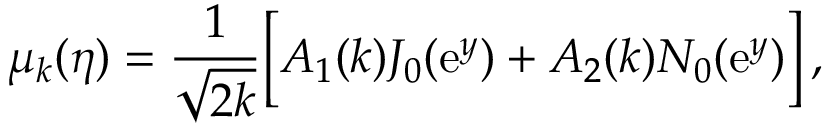Convert formula to latex. <formula><loc_0><loc_0><loc_500><loc_500>\mu _ { k } ( \eta ) = \frac { 1 } { \sqrt { 2 k } } \left [ A _ { 1 } ( k ) J _ { 0 } ( e ^ { y } ) + A _ { 2 } ( k ) N _ { 0 } ( e ^ { y } ) \right ] \, ,</formula> 